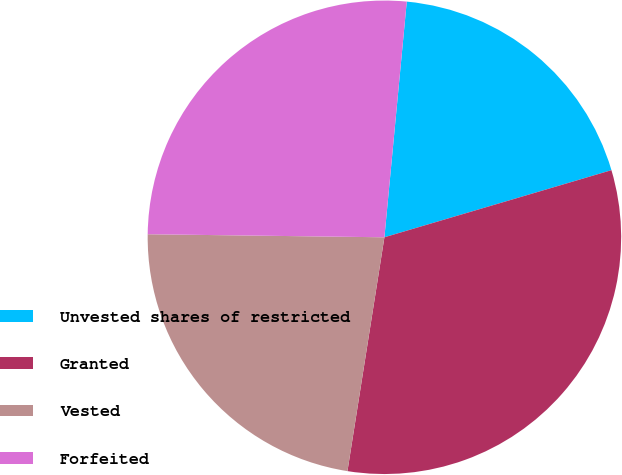Convert chart to OTSL. <chart><loc_0><loc_0><loc_500><loc_500><pie_chart><fcel>Unvested shares of restricted<fcel>Granted<fcel>Vested<fcel>Forfeited<nl><fcel>18.92%<fcel>32.07%<fcel>22.71%<fcel>26.3%<nl></chart> 